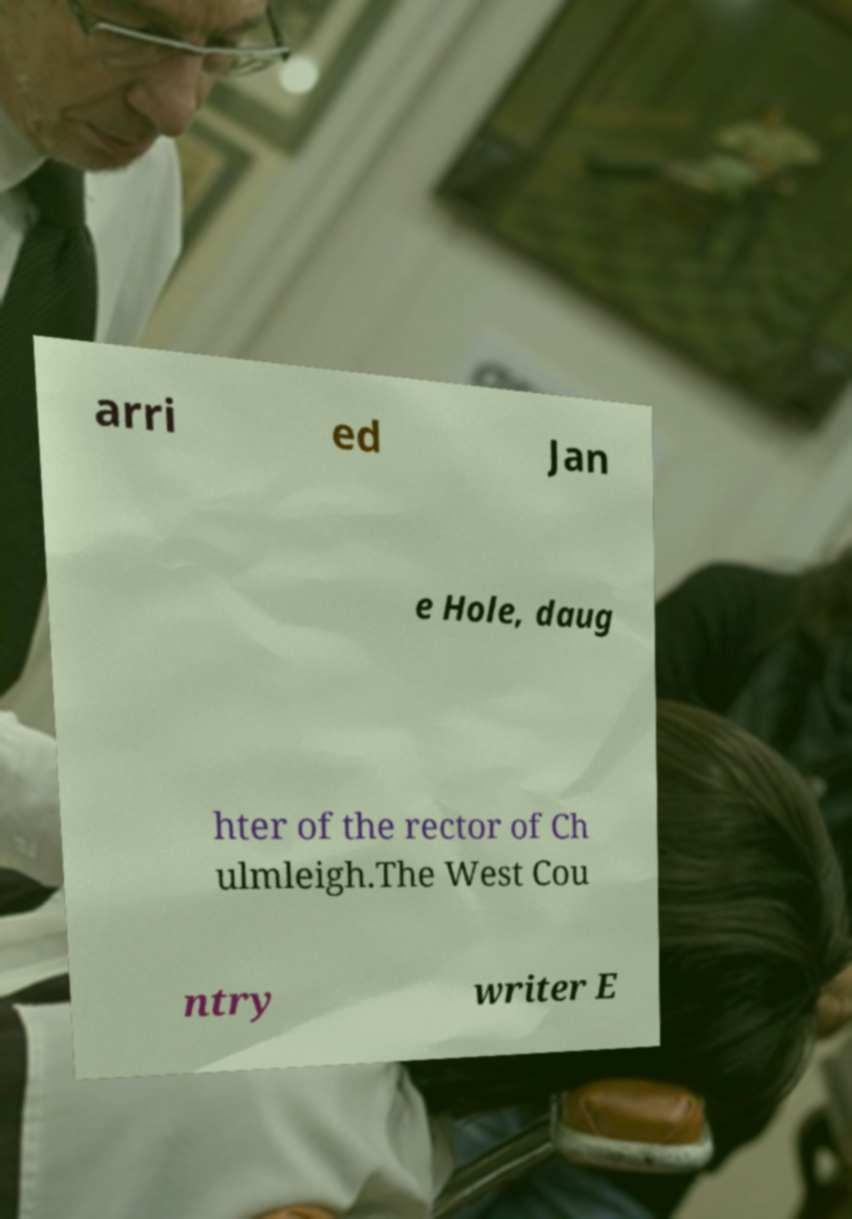I need the written content from this picture converted into text. Can you do that? arri ed Jan e Hole, daug hter of the rector of Ch ulmleigh.The West Cou ntry writer E 